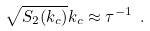<formula> <loc_0><loc_0><loc_500><loc_500>\sqrt { S _ { 2 } ( k _ { c } ) } k _ { c } \approx \tau ^ { - 1 } \ .</formula> 